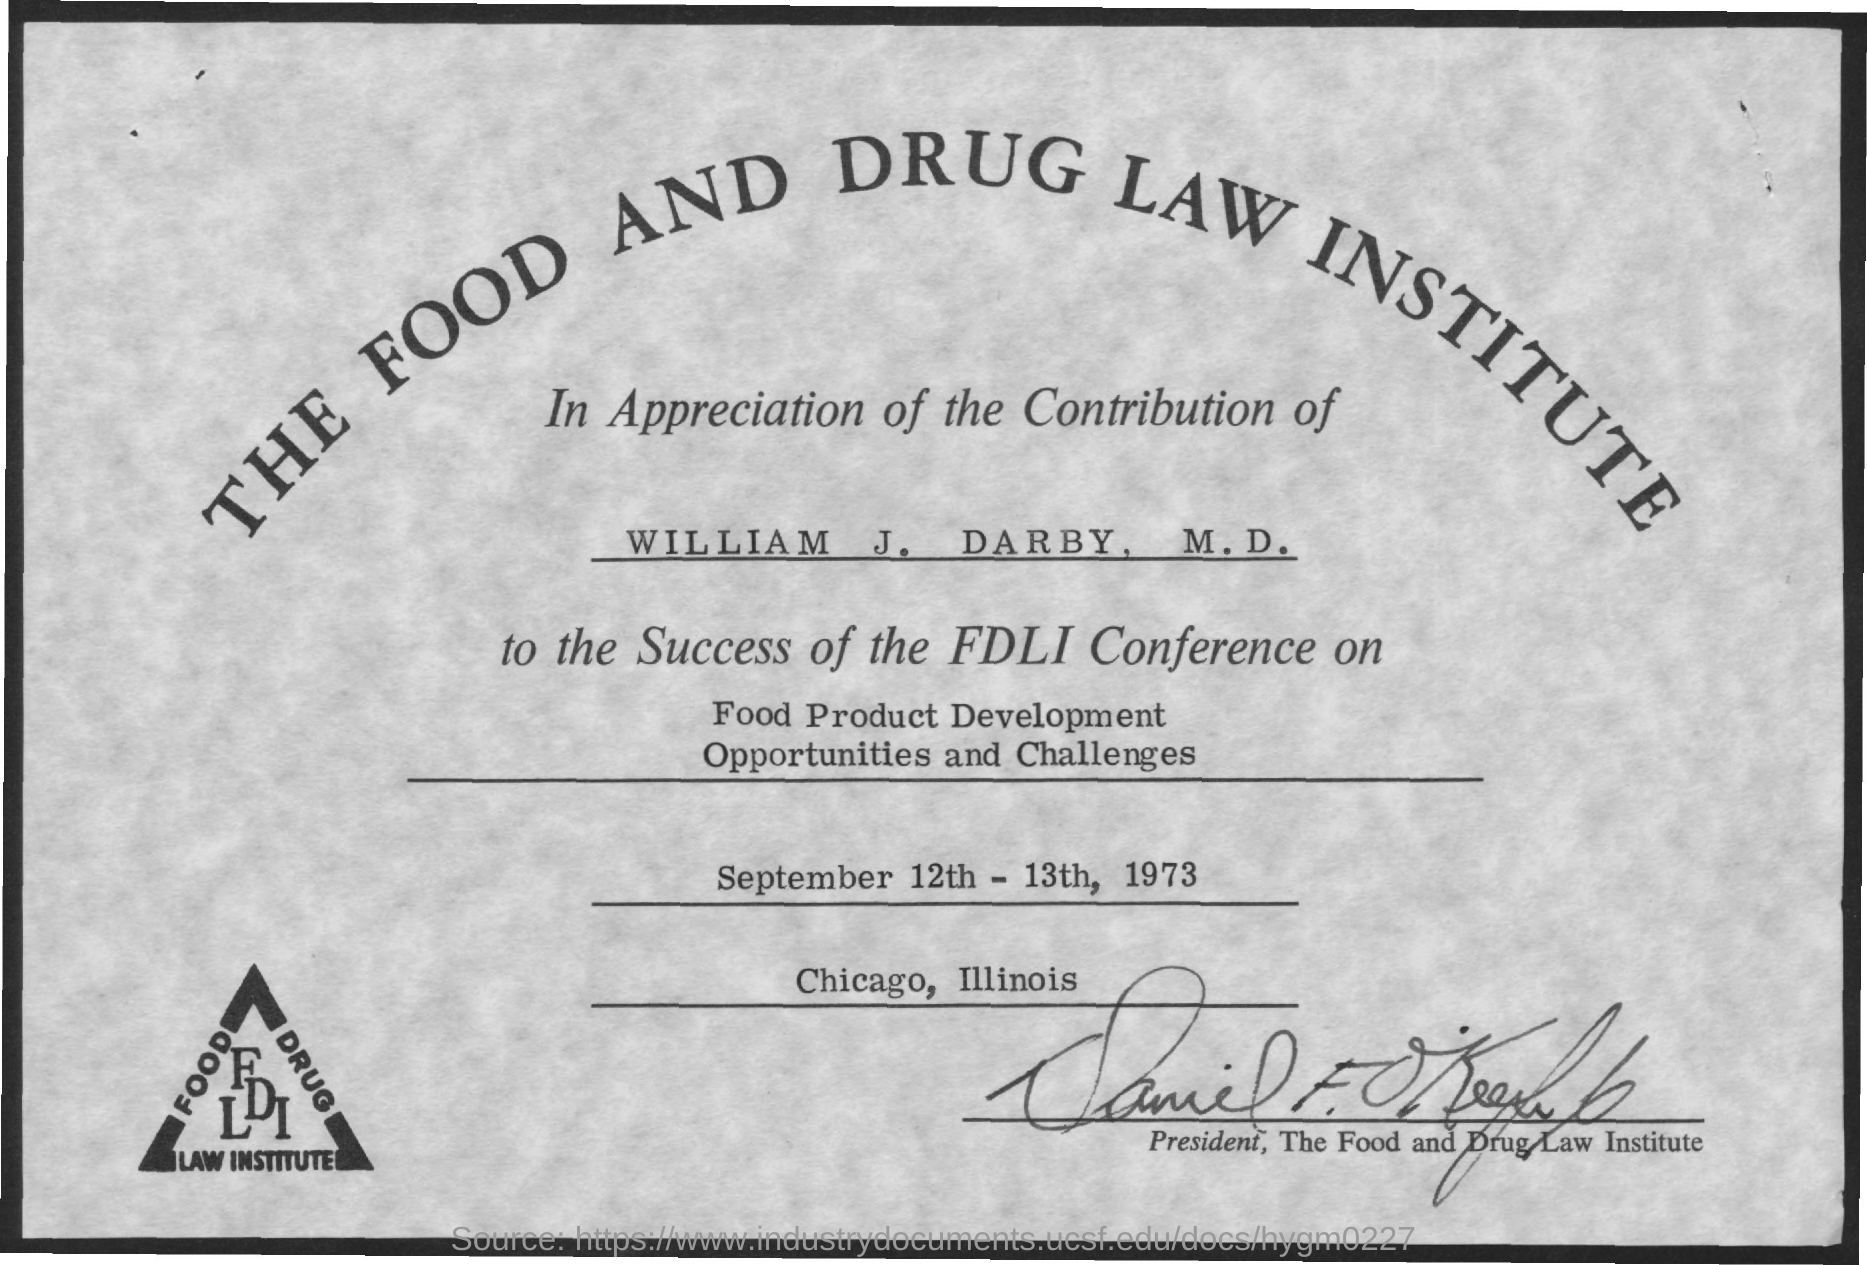Mention a couple of crucial points in this snapshot. William J. Darby, M.D., whose contribution is appreciated, is acknowledged for his outstanding work in the field. The certificate is from the Food and Drug Law Institute. The conference name is fdli.. The conference was held on September 12th and 13th of 1973. The conference will focus on exploring the opportunities and challenges associated with food product development. 